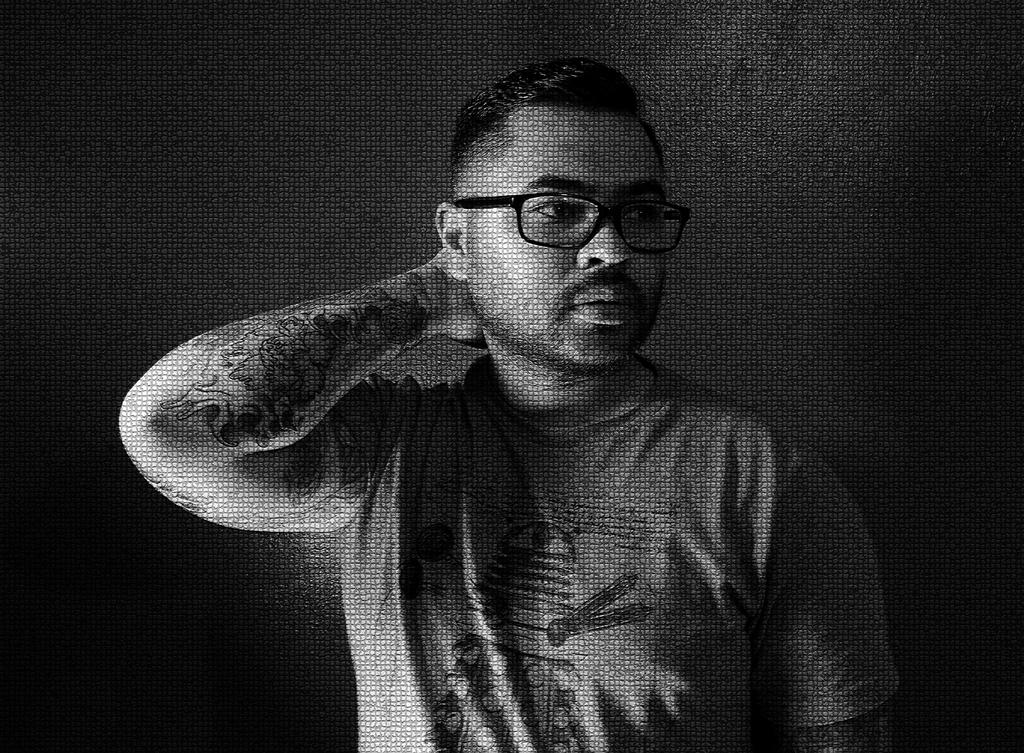What is the color scheme of the image? The image is black and white. What is the main subject of the image? There is a person standing at the center of the image. What is the person wearing on their upper body? The person is wearing a t-shirt. What type of eyewear is the person wearing? The person is wearing black color spectacles. Can you describe any additional features on the person's body? There is a tattoo on the person's arm. What type of rhythm can be heard coming from the roof in the image? There is no roof or rhythm present in the image; it features a person standing at the center with a tattoo on their arm. 